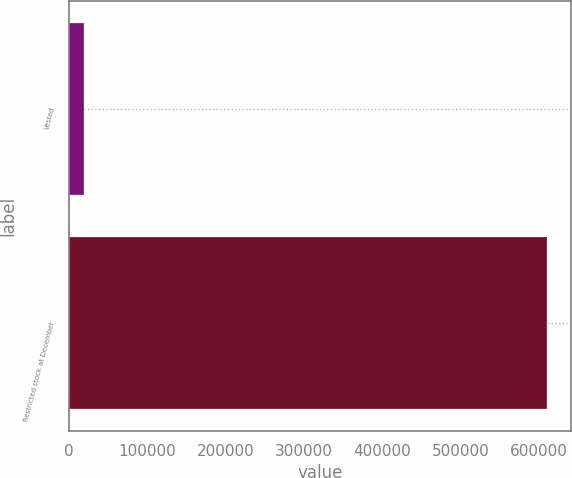Convert chart. <chart><loc_0><loc_0><loc_500><loc_500><bar_chart><fcel>Vested<fcel>Restricted stock at December<nl><fcel>19300<fcel>610380<nl></chart> 